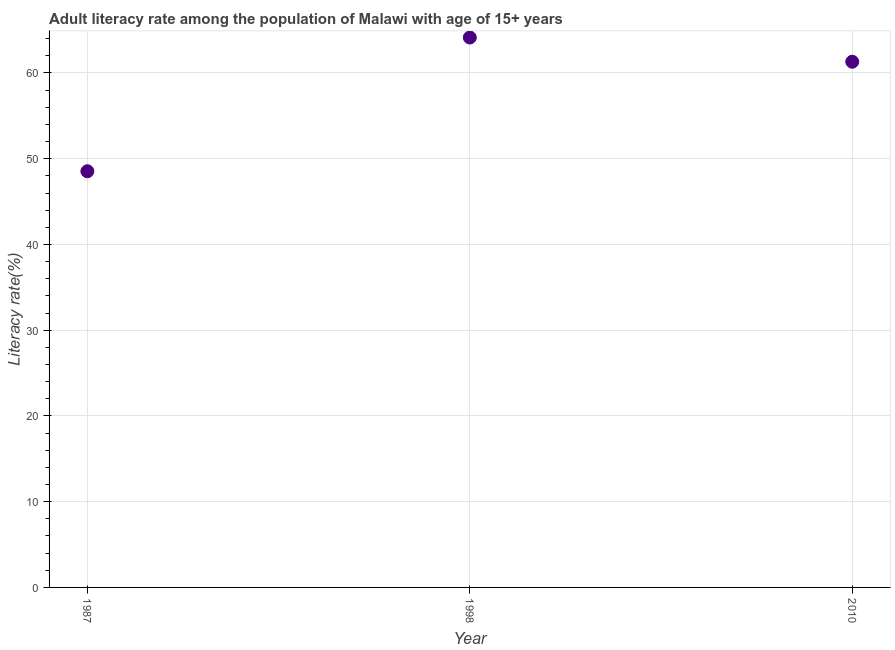What is the adult literacy rate in 1987?
Make the answer very short. 48.54. Across all years, what is the maximum adult literacy rate?
Your answer should be very brief. 64.13. Across all years, what is the minimum adult literacy rate?
Make the answer very short. 48.54. In which year was the adult literacy rate maximum?
Make the answer very short. 1998. What is the sum of the adult literacy rate?
Provide a succinct answer. 173.98. What is the difference between the adult literacy rate in 1987 and 2010?
Provide a short and direct response. -12.77. What is the average adult literacy rate per year?
Offer a very short reply. 57.99. What is the median adult literacy rate?
Your answer should be very brief. 61.31. Do a majority of the years between 2010 and 1998 (inclusive) have adult literacy rate greater than 26 %?
Keep it short and to the point. No. What is the ratio of the adult literacy rate in 1987 to that in 1998?
Ensure brevity in your answer.  0.76. Is the adult literacy rate in 1987 less than that in 1998?
Provide a short and direct response. Yes. Is the difference between the adult literacy rate in 1987 and 1998 greater than the difference between any two years?
Your answer should be compact. Yes. What is the difference between the highest and the second highest adult literacy rate?
Provide a succinct answer. 2.82. Is the sum of the adult literacy rate in 1998 and 2010 greater than the maximum adult literacy rate across all years?
Ensure brevity in your answer.  Yes. What is the difference between the highest and the lowest adult literacy rate?
Your response must be concise. 15.6. In how many years, is the adult literacy rate greater than the average adult literacy rate taken over all years?
Keep it short and to the point. 2. Does the adult literacy rate monotonically increase over the years?
Provide a succinct answer. No. How many dotlines are there?
Make the answer very short. 1. Does the graph contain grids?
Make the answer very short. Yes. What is the title of the graph?
Keep it short and to the point. Adult literacy rate among the population of Malawi with age of 15+ years. What is the label or title of the X-axis?
Make the answer very short. Year. What is the label or title of the Y-axis?
Provide a short and direct response. Literacy rate(%). What is the Literacy rate(%) in 1987?
Your response must be concise. 48.54. What is the Literacy rate(%) in 1998?
Make the answer very short. 64.13. What is the Literacy rate(%) in 2010?
Your response must be concise. 61.31. What is the difference between the Literacy rate(%) in 1987 and 1998?
Offer a terse response. -15.6. What is the difference between the Literacy rate(%) in 1987 and 2010?
Make the answer very short. -12.77. What is the difference between the Literacy rate(%) in 1998 and 2010?
Give a very brief answer. 2.82. What is the ratio of the Literacy rate(%) in 1987 to that in 1998?
Offer a very short reply. 0.76. What is the ratio of the Literacy rate(%) in 1987 to that in 2010?
Give a very brief answer. 0.79. What is the ratio of the Literacy rate(%) in 1998 to that in 2010?
Your response must be concise. 1.05. 